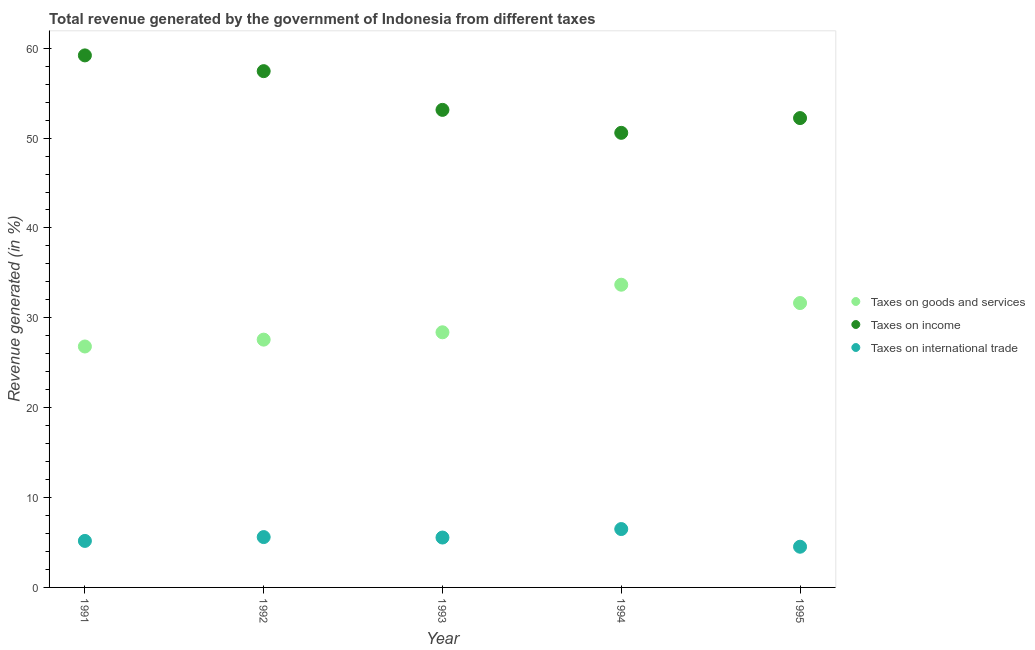How many different coloured dotlines are there?
Offer a very short reply. 3. What is the percentage of revenue generated by taxes on goods and services in 1995?
Offer a very short reply. 31.64. Across all years, what is the maximum percentage of revenue generated by taxes on income?
Provide a succinct answer. 59.2. Across all years, what is the minimum percentage of revenue generated by tax on international trade?
Offer a very short reply. 4.53. What is the total percentage of revenue generated by taxes on goods and services in the graph?
Provide a succinct answer. 148.1. What is the difference between the percentage of revenue generated by tax on international trade in 1991 and that in 1992?
Your answer should be very brief. -0.43. What is the difference between the percentage of revenue generated by taxes on income in 1994 and the percentage of revenue generated by taxes on goods and services in 1993?
Provide a succinct answer. 22.19. What is the average percentage of revenue generated by taxes on income per year?
Keep it short and to the point. 54.52. In the year 1992, what is the difference between the percentage of revenue generated by taxes on income and percentage of revenue generated by taxes on goods and services?
Keep it short and to the point. 29.87. In how many years, is the percentage of revenue generated by taxes on goods and services greater than 4 %?
Keep it short and to the point. 5. What is the ratio of the percentage of revenue generated by taxes on goods and services in 1991 to that in 1995?
Your answer should be very brief. 0.85. What is the difference between the highest and the second highest percentage of revenue generated by taxes on goods and services?
Keep it short and to the point. 2.04. What is the difference between the highest and the lowest percentage of revenue generated by tax on international trade?
Your answer should be compact. 1.97. In how many years, is the percentage of revenue generated by taxes on income greater than the average percentage of revenue generated by taxes on income taken over all years?
Make the answer very short. 2. Is it the case that in every year, the sum of the percentage of revenue generated by taxes on goods and services and percentage of revenue generated by taxes on income is greater than the percentage of revenue generated by tax on international trade?
Your response must be concise. Yes. Does the percentage of revenue generated by tax on international trade monotonically increase over the years?
Your response must be concise. No. Is the percentage of revenue generated by taxes on income strictly greater than the percentage of revenue generated by tax on international trade over the years?
Make the answer very short. Yes. Is the percentage of revenue generated by tax on international trade strictly less than the percentage of revenue generated by taxes on income over the years?
Offer a very short reply. Yes. How many dotlines are there?
Your answer should be compact. 3. Where does the legend appear in the graph?
Keep it short and to the point. Center right. How many legend labels are there?
Your answer should be very brief. 3. What is the title of the graph?
Offer a terse response. Total revenue generated by the government of Indonesia from different taxes. What is the label or title of the Y-axis?
Offer a very short reply. Revenue generated (in %). What is the Revenue generated (in %) of Taxes on goods and services in 1991?
Give a very brief answer. 26.81. What is the Revenue generated (in %) of Taxes on income in 1991?
Provide a short and direct response. 59.2. What is the Revenue generated (in %) of Taxes on international trade in 1991?
Keep it short and to the point. 5.17. What is the Revenue generated (in %) in Taxes on goods and services in 1992?
Your answer should be very brief. 27.57. What is the Revenue generated (in %) in Taxes on income in 1992?
Keep it short and to the point. 57.45. What is the Revenue generated (in %) of Taxes on international trade in 1992?
Provide a succinct answer. 5.6. What is the Revenue generated (in %) of Taxes on goods and services in 1993?
Your answer should be very brief. 28.39. What is the Revenue generated (in %) in Taxes on income in 1993?
Your answer should be compact. 53.14. What is the Revenue generated (in %) in Taxes on international trade in 1993?
Provide a short and direct response. 5.55. What is the Revenue generated (in %) in Taxes on goods and services in 1994?
Provide a succinct answer. 33.68. What is the Revenue generated (in %) of Taxes on income in 1994?
Keep it short and to the point. 50.58. What is the Revenue generated (in %) of Taxes on international trade in 1994?
Your answer should be very brief. 6.5. What is the Revenue generated (in %) in Taxes on goods and services in 1995?
Offer a very short reply. 31.64. What is the Revenue generated (in %) of Taxes on income in 1995?
Make the answer very short. 52.23. What is the Revenue generated (in %) of Taxes on international trade in 1995?
Your response must be concise. 4.53. Across all years, what is the maximum Revenue generated (in %) in Taxes on goods and services?
Your answer should be very brief. 33.68. Across all years, what is the maximum Revenue generated (in %) in Taxes on income?
Ensure brevity in your answer.  59.2. Across all years, what is the maximum Revenue generated (in %) of Taxes on international trade?
Offer a very short reply. 6.5. Across all years, what is the minimum Revenue generated (in %) of Taxes on goods and services?
Provide a short and direct response. 26.81. Across all years, what is the minimum Revenue generated (in %) of Taxes on income?
Ensure brevity in your answer.  50.58. Across all years, what is the minimum Revenue generated (in %) in Taxes on international trade?
Provide a short and direct response. 4.53. What is the total Revenue generated (in %) of Taxes on goods and services in the graph?
Provide a short and direct response. 148.1. What is the total Revenue generated (in %) in Taxes on income in the graph?
Offer a very short reply. 272.6. What is the total Revenue generated (in %) of Taxes on international trade in the graph?
Offer a terse response. 27.35. What is the difference between the Revenue generated (in %) in Taxes on goods and services in 1991 and that in 1992?
Keep it short and to the point. -0.76. What is the difference between the Revenue generated (in %) of Taxes on income in 1991 and that in 1992?
Make the answer very short. 1.75. What is the difference between the Revenue generated (in %) in Taxes on international trade in 1991 and that in 1992?
Provide a succinct answer. -0.43. What is the difference between the Revenue generated (in %) in Taxes on goods and services in 1991 and that in 1993?
Keep it short and to the point. -1.58. What is the difference between the Revenue generated (in %) of Taxes on income in 1991 and that in 1993?
Give a very brief answer. 6.06. What is the difference between the Revenue generated (in %) of Taxes on international trade in 1991 and that in 1993?
Give a very brief answer. -0.38. What is the difference between the Revenue generated (in %) of Taxes on goods and services in 1991 and that in 1994?
Give a very brief answer. -6.87. What is the difference between the Revenue generated (in %) in Taxes on income in 1991 and that in 1994?
Give a very brief answer. 8.62. What is the difference between the Revenue generated (in %) in Taxes on international trade in 1991 and that in 1994?
Make the answer very short. -1.32. What is the difference between the Revenue generated (in %) in Taxes on goods and services in 1991 and that in 1995?
Your response must be concise. -4.83. What is the difference between the Revenue generated (in %) in Taxes on income in 1991 and that in 1995?
Your answer should be very brief. 6.98. What is the difference between the Revenue generated (in %) in Taxes on international trade in 1991 and that in 1995?
Keep it short and to the point. 0.65. What is the difference between the Revenue generated (in %) of Taxes on goods and services in 1992 and that in 1993?
Ensure brevity in your answer.  -0.82. What is the difference between the Revenue generated (in %) of Taxes on income in 1992 and that in 1993?
Your answer should be very brief. 4.31. What is the difference between the Revenue generated (in %) in Taxes on international trade in 1992 and that in 1993?
Keep it short and to the point. 0.05. What is the difference between the Revenue generated (in %) in Taxes on goods and services in 1992 and that in 1994?
Make the answer very short. -6.11. What is the difference between the Revenue generated (in %) in Taxes on income in 1992 and that in 1994?
Your response must be concise. 6.86. What is the difference between the Revenue generated (in %) of Taxes on international trade in 1992 and that in 1994?
Provide a succinct answer. -0.89. What is the difference between the Revenue generated (in %) in Taxes on goods and services in 1992 and that in 1995?
Make the answer very short. -4.07. What is the difference between the Revenue generated (in %) of Taxes on income in 1992 and that in 1995?
Provide a short and direct response. 5.22. What is the difference between the Revenue generated (in %) of Taxes on international trade in 1992 and that in 1995?
Offer a very short reply. 1.07. What is the difference between the Revenue generated (in %) of Taxes on goods and services in 1993 and that in 1994?
Your response must be concise. -5.29. What is the difference between the Revenue generated (in %) in Taxes on income in 1993 and that in 1994?
Offer a very short reply. 2.55. What is the difference between the Revenue generated (in %) in Taxes on international trade in 1993 and that in 1994?
Offer a very short reply. -0.94. What is the difference between the Revenue generated (in %) in Taxes on goods and services in 1993 and that in 1995?
Your answer should be very brief. -3.25. What is the difference between the Revenue generated (in %) of Taxes on income in 1993 and that in 1995?
Make the answer very short. 0.91. What is the difference between the Revenue generated (in %) of Taxes on international trade in 1993 and that in 1995?
Your response must be concise. 1.02. What is the difference between the Revenue generated (in %) of Taxes on goods and services in 1994 and that in 1995?
Your answer should be very brief. 2.04. What is the difference between the Revenue generated (in %) of Taxes on income in 1994 and that in 1995?
Make the answer very short. -1.64. What is the difference between the Revenue generated (in %) of Taxes on international trade in 1994 and that in 1995?
Your answer should be very brief. 1.97. What is the difference between the Revenue generated (in %) of Taxes on goods and services in 1991 and the Revenue generated (in %) of Taxes on income in 1992?
Your answer should be very brief. -30.64. What is the difference between the Revenue generated (in %) in Taxes on goods and services in 1991 and the Revenue generated (in %) in Taxes on international trade in 1992?
Offer a terse response. 21.21. What is the difference between the Revenue generated (in %) of Taxes on income in 1991 and the Revenue generated (in %) of Taxes on international trade in 1992?
Give a very brief answer. 53.6. What is the difference between the Revenue generated (in %) in Taxes on goods and services in 1991 and the Revenue generated (in %) in Taxes on income in 1993?
Offer a very short reply. -26.33. What is the difference between the Revenue generated (in %) in Taxes on goods and services in 1991 and the Revenue generated (in %) in Taxes on international trade in 1993?
Offer a very short reply. 21.26. What is the difference between the Revenue generated (in %) of Taxes on income in 1991 and the Revenue generated (in %) of Taxes on international trade in 1993?
Give a very brief answer. 53.65. What is the difference between the Revenue generated (in %) of Taxes on goods and services in 1991 and the Revenue generated (in %) of Taxes on income in 1994?
Keep it short and to the point. -23.77. What is the difference between the Revenue generated (in %) in Taxes on goods and services in 1991 and the Revenue generated (in %) in Taxes on international trade in 1994?
Keep it short and to the point. 20.31. What is the difference between the Revenue generated (in %) in Taxes on income in 1991 and the Revenue generated (in %) in Taxes on international trade in 1994?
Ensure brevity in your answer.  52.71. What is the difference between the Revenue generated (in %) of Taxes on goods and services in 1991 and the Revenue generated (in %) of Taxes on income in 1995?
Provide a succinct answer. -25.42. What is the difference between the Revenue generated (in %) of Taxes on goods and services in 1991 and the Revenue generated (in %) of Taxes on international trade in 1995?
Your answer should be very brief. 22.28. What is the difference between the Revenue generated (in %) of Taxes on income in 1991 and the Revenue generated (in %) of Taxes on international trade in 1995?
Offer a very short reply. 54.67. What is the difference between the Revenue generated (in %) of Taxes on goods and services in 1992 and the Revenue generated (in %) of Taxes on income in 1993?
Offer a terse response. -25.57. What is the difference between the Revenue generated (in %) in Taxes on goods and services in 1992 and the Revenue generated (in %) in Taxes on international trade in 1993?
Give a very brief answer. 22.02. What is the difference between the Revenue generated (in %) of Taxes on income in 1992 and the Revenue generated (in %) of Taxes on international trade in 1993?
Provide a short and direct response. 51.9. What is the difference between the Revenue generated (in %) of Taxes on goods and services in 1992 and the Revenue generated (in %) of Taxes on income in 1994?
Ensure brevity in your answer.  -23.01. What is the difference between the Revenue generated (in %) of Taxes on goods and services in 1992 and the Revenue generated (in %) of Taxes on international trade in 1994?
Your response must be concise. 21.08. What is the difference between the Revenue generated (in %) of Taxes on income in 1992 and the Revenue generated (in %) of Taxes on international trade in 1994?
Ensure brevity in your answer.  50.95. What is the difference between the Revenue generated (in %) of Taxes on goods and services in 1992 and the Revenue generated (in %) of Taxes on income in 1995?
Keep it short and to the point. -24.65. What is the difference between the Revenue generated (in %) of Taxes on goods and services in 1992 and the Revenue generated (in %) of Taxes on international trade in 1995?
Provide a succinct answer. 23.04. What is the difference between the Revenue generated (in %) in Taxes on income in 1992 and the Revenue generated (in %) in Taxes on international trade in 1995?
Offer a very short reply. 52.92. What is the difference between the Revenue generated (in %) in Taxes on goods and services in 1993 and the Revenue generated (in %) in Taxes on income in 1994?
Ensure brevity in your answer.  -22.19. What is the difference between the Revenue generated (in %) of Taxes on goods and services in 1993 and the Revenue generated (in %) of Taxes on international trade in 1994?
Provide a short and direct response. 21.89. What is the difference between the Revenue generated (in %) in Taxes on income in 1993 and the Revenue generated (in %) in Taxes on international trade in 1994?
Make the answer very short. 46.64. What is the difference between the Revenue generated (in %) of Taxes on goods and services in 1993 and the Revenue generated (in %) of Taxes on income in 1995?
Offer a very short reply. -23.84. What is the difference between the Revenue generated (in %) of Taxes on goods and services in 1993 and the Revenue generated (in %) of Taxes on international trade in 1995?
Your answer should be compact. 23.86. What is the difference between the Revenue generated (in %) of Taxes on income in 1993 and the Revenue generated (in %) of Taxes on international trade in 1995?
Your response must be concise. 48.61. What is the difference between the Revenue generated (in %) of Taxes on goods and services in 1994 and the Revenue generated (in %) of Taxes on income in 1995?
Provide a short and direct response. -18.54. What is the difference between the Revenue generated (in %) in Taxes on goods and services in 1994 and the Revenue generated (in %) in Taxes on international trade in 1995?
Your answer should be compact. 29.16. What is the difference between the Revenue generated (in %) of Taxes on income in 1994 and the Revenue generated (in %) of Taxes on international trade in 1995?
Your answer should be compact. 46.06. What is the average Revenue generated (in %) in Taxes on goods and services per year?
Provide a short and direct response. 29.62. What is the average Revenue generated (in %) in Taxes on income per year?
Offer a terse response. 54.52. What is the average Revenue generated (in %) of Taxes on international trade per year?
Make the answer very short. 5.47. In the year 1991, what is the difference between the Revenue generated (in %) in Taxes on goods and services and Revenue generated (in %) in Taxes on income?
Give a very brief answer. -32.39. In the year 1991, what is the difference between the Revenue generated (in %) of Taxes on goods and services and Revenue generated (in %) of Taxes on international trade?
Make the answer very short. 21.64. In the year 1991, what is the difference between the Revenue generated (in %) in Taxes on income and Revenue generated (in %) in Taxes on international trade?
Make the answer very short. 54.03. In the year 1992, what is the difference between the Revenue generated (in %) of Taxes on goods and services and Revenue generated (in %) of Taxes on income?
Provide a succinct answer. -29.87. In the year 1992, what is the difference between the Revenue generated (in %) in Taxes on goods and services and Revenue generated (in %) in Taxes on international trade?
Ensure brevity in your answer.  21.97. In the year 1992, what is the difference between the Revenue generated (in %) in Taxes on income and Revenue generated (in %) in Taxes on international trade?
Ensure brevity in your answer.  51.85. In the year 1993, what is the difference between the Revenue generated (in %) of Taxes on goods and services and Revenue generated (in %) of Taxes on income?
Offer a very short reply. -24.75. In the year 1993, what is the difference between the Revenue generated (in %) in Taxes on goods and services and Revenue generated (in %) in Taxes on international trade?
Make the answer very short. 22.84. In the year 1993, what is the difference between the Revenue generated (in %) of Taxes on income and Revenue generated (in %) of Taxes on international trade?
Provide a succinct answer. 47.59. In the year 1994, what is the difference between the Revenue generated (in %) of Taxes on goods and services and Revenue generated (in %) of Taxes on income?
Offer a very short reply. -16.9. In the year 1994, what is the difference between the Revenue generated (in %) of Taxes on goods and services and Revenue generated (in %) of Taxes on international trade?
Provide a succinct answer. 27.19. In the year 1994, what is the difference between the Revenue generated (in %) in Taxes on income and Revenue generated (in %) in Taxes on international trade?
Give a very brief answer. 44.09. In the year 1995, what is the difference between the Revenue generated (in %) of Taxes on goods and services and Revenue generated (in %) of Taxes on income?
Offer a very short reply. -20.58. In the year 1995, what is the difference between the Revenue generated (in %) of Taxes on goods and services and Revenue generated (in %) of Taxes on international trade?
Offer a terse response. 27.12. In the year 1995, what is the difference between the Revenue generated (in %) in Taxes on income and Revenue generated (in %) in Taxes on international trade?
Ensure brevity in your answer.  47.7. What is the ratio of the Revenue generated (in %) of Taxes on goods and services in 1991 to that in 1992?
Make the answer very short. 0.97. What is the ratio of the Revenue generated (in %) of Taxes on income in 1991 to that in 1992?
Offer a terse response. 1.03. What is the ratio of the Revenue generated (in %) in Taxes on international trade in 1991 to that in 1992?
Give a very brief answer. 0.92. What is the ratio of the Revenue generated (in %) in Taxes on goods and services in 1991 to that in 1993?
Make the answer very short. 0.94. What is the ratio of the Revenue generated (in %) of Taxes on income in 1991 to that in 1993?
Provide a succinct answer. 1.11. What is the ratio of the Revenue generated (in %) of Taxes on international trade in 1991 to that in 1993?
Provide a short and direct response. 0.93. What is the ratio of the Revenue generated (in %) in Taxes on goods and services in 1991 to that in 1994?
Your answer should be compact. 0.8. What is the ratio of the Revenue generated (in %) in Taxes on income in 1991 to that in 1994?
Offer a terse response. 1.17. What is the ratio of the Revenue generated (in %) of Taxes on international trade in 1991 to that in 1994?
Provide a short and direct response. 0.8. What is the ratio of the Revenue generated (in %) in Taxes on goods and services in 1991 to that in 1995?
Make the answer very short. 0.85. What is the ratio of the Revenue generated (in %) of Taxes on income in 1991 to that in 1995?
Keep it short and to the point. 1.13. What is the ratio of the Revenue generated (in %) in Taxes on international trade in 1991 to that in 1995?
Offer a very short reply. 1.14. What is the ratio of the Revenue generated (in %) in Taxes on goods and services in 1992 to that in 1993?
Provide a short and direct response. 0.97. What is the ratio of the Revenue generated (in %) of Taxes on income in 1992 to that in 1993?
Make the answer very short. 1.08. What is the ratio of the Revenue generated (in %) of Taxes on international trade in 1992 to that in 1993?
Ensure brevity in your answer.  1.01. What is the ratio of the Revenue generated (in %) in Taxes on goods and services in 1992 to that in 1994?
Provide a short and direct response. 0.82. What is the ratio of the Revenue generated (in %) in Taxes on income in 1992 to that in 1994?
Give a very brief answer. 1.14. What is the ratio of the Revenue generated (in %) in Taxes on international trade in 1992 to that in 1994?
Provide a succinct answer. 0.86. What is the ratio of the Revenue generated (in %) of Taxes on goods and services in 1992 to that in 1995?
Your answer should be very brief. 0.87. What is the ratio of the Revenue generated (in %) of Taxes on international trade in 1992 to that in 1995?
Provide a short and direct response. 1.24. What is the ratio of the Revenue generated (in %) in Taxes on goods and services in 1993 to that in 1994?
Offer a very short reply. 0.84. What is the ratio of the Revenue generated (in %) of Taxes on income in 1993 to that in 1994?
Provide a short and direct response. 1.05. What is the ratio of the Revenue generated (in %) in Taxes on international trade in 1993 to that in 1994?
Your answer should be very brief. 0.85. What is the ratio of the Revenue generated (in %) of Taxes on goods and services in 1993 to that in 1995?
Your answer should be compact. 0.9. What is the ratio of the Revenue generated (in %) of Taxes on income in 1993 to that in 1995?
Make the answer very short. 1.02. What is the ratio of the Revenue generated (in %) in Taxes on international trade in 1993 to that in 1995?
Ensure brevity in your answer.  1.23. What is the ratio of the Revenue generated (in %) of Taxes on goods and services in 1994 to that in 1995?
Provide a succinct answer. 1.06. What is the ratio of the Revenue generated (in %) of Taxes on income in 1994 to that in 1995?
Keep it short and to the point. 0.97. What is the ratio of the Revenue generated (in %) of Taxes on international trade in 1994 to that in 1995?
Your answer should be compact. 1.43. What is the difference between the highest and the second highest Revenue generated (in %) in Taxes on goods and services?
Your response must be concise. 2.04. What is the difference between the highest and the second highest Revenue generated (in %) of Taxes on income?
Your answer should be compact. 1.75. What is the difference between the highest and the second highest Revenue generated (in %) of Taxes on international trade?
Your response must be concise. 0.89. What is the difference between the highest and the lowest Revenue generated (in %) in Taxes on goods and services?
Your response must be concise. 6.87. What is the difference between the highest and the lowest Revenue generated (in %) of Taxes on income?
Offer a very short reply. 8.62. What is the difference between the highest and the lowest Revenue generated (in %) in Taxes on international trade?
Keep it short and to the point. 1.97. 